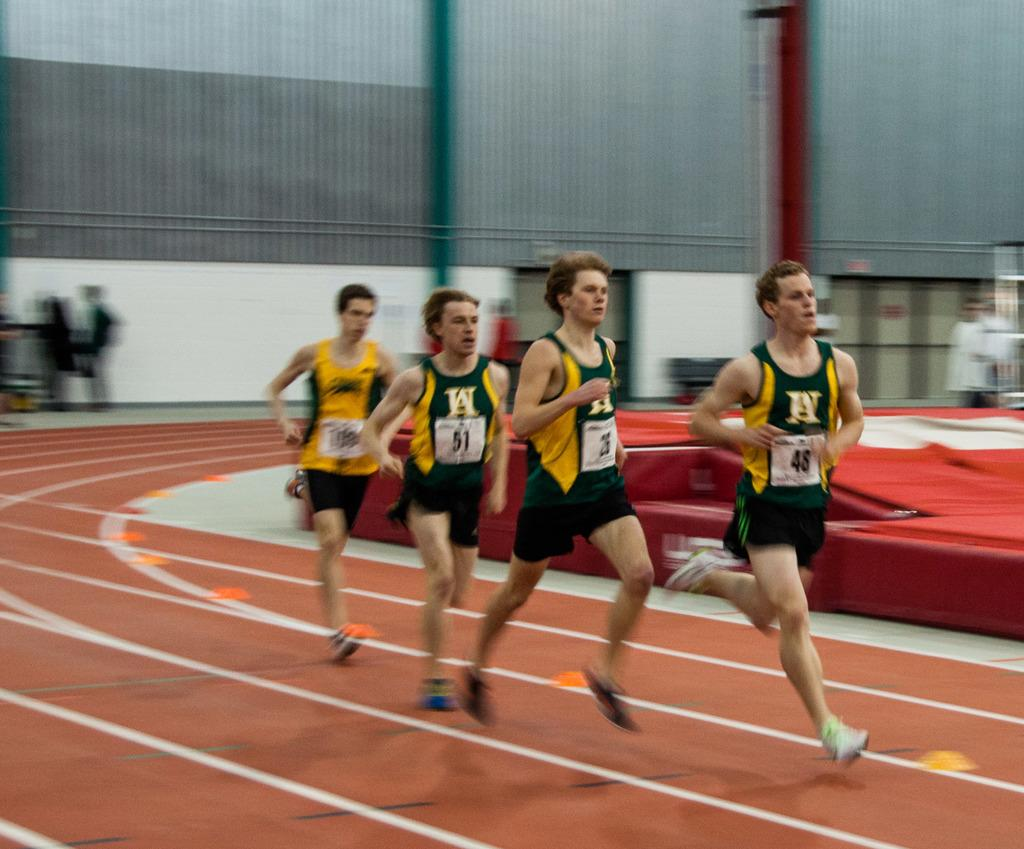What are the people in the image doing? The people in the image are running. What can be seen in the background of the image? Walls are visible in the background of the image. Are there any other people in the image besides the ones running? Yes, there are people in the background of the image. What is the mass of the spring in the image? There is no spring present in the image. 